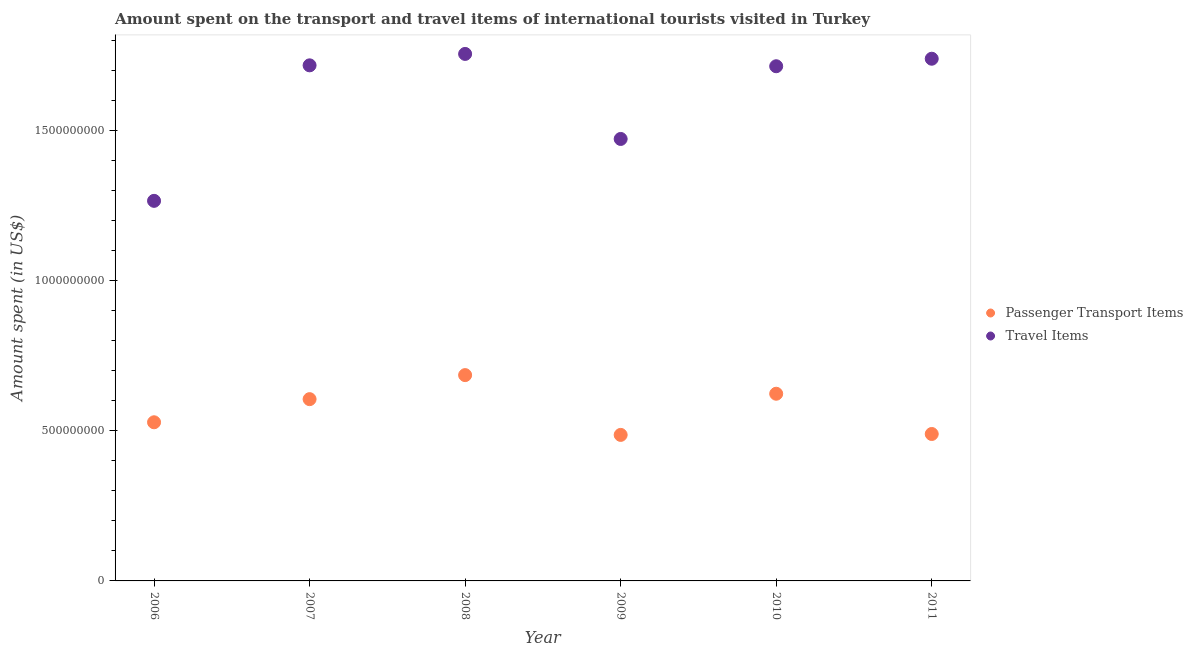How many different coloured dotlines are there?
Keep it short and to the point. 2. Is the number of dotlines equal to the number of legend labels?
Ensure brevity in your answer.  Yes. What is the amount spent on passenger transport items in 2007?
Your answer should be compact. 6.05e+08. Across all years, what is the maximum amount spent on passenger transport items?
Your answer should be very brief. 6.85e+08. Across all years, what is the minimum amount spent in travel items?
Your answer should be compact. 1.26e+09. In which year was the amount spent in travel items maximum?
Ensure brevity in your answer.  2008. What is the total amount spent on passenger transport items in the graph?
Make the answer very short. 3.42e+09. What is the difference between the amount spent on passenger transport items in 2008 and that in 2010?
Provide a short and direct response. 6.20e+07. What is the difference between the amount spent in travel items in 2006 and the amount spent on passenger transport items in 2009?
Offer a very short reply. 7.79e+08. What is the average amount spent on passenger transport items per year?
Give a very brief answer. 5.69e+08. In the year 2011, what is the difference between the amount spent in travel items and amount spent on passenger transport items?
Your response must be concise. 1.25e+09. What is the ratio of the amount spent on passenger transport items in 2008 to that in 2010?
Make the answer very short. 1.1. Is the amount spent in travel items in 2006 less than that in 2011?
Offer a very short reply. Yes. Is the difference between the amount spent on passenger transport items in 2008 and 2010 greater than the difference between the amount spent in travel items in 2008 and 2010?
Your answer should be very brief. Yes. What is the difference between the highest and the second highest amount spent on passenger transport items?
Your answer should be very brief. 6.20e+07. What is the difference between the highest and the lowest amount spent in travel items?
Make the answer very short. 4.89e+08. Is the amount spent on passenger transport items strictly less than the amount spent in travel items over the years?
Your answer should be very brief. Yes. What is the difference between two consecutive major ticks on the Y-axis?
Provide a succinct answer. 5.00e+08. Are the values on the major ticks of Y-axis written in scientific E-notation?
Provide a short and direct response. No. Does the graph contain any zero values?
Make the answer very short. No. How many legend labels are there?
Your response must be concise. 2. What is the title of the graph?
Keep it short and to the point. Amount spent on the transport and travel items of international tourists visited in Turkey. What is the label or title of the Y-axis?
Provide a succinct answer. Amount spent (in US$). What is the Amount spent (in US$) in Passenger Transport Items in 2006?
Offer a very short reply. 5.28e+08. What is the Amount spent (in US$) of Travel Items in 2006?
Provide a succinct answer. 1.26e+09. What is the Amount spent (in US$) of Passenger Transport Items in 2007?
Give a very brief answer. 6.05e+08. What is the Amount spent (in US$) of Travel Items in 2007?
Provide a short and direct response. 1.72e+09. What is the Amount spent (in US$) in Passenger Transport Items in 2008?
Your answer should be very brief. 6.85e+08. What is the Amount spent (in US$) in Travel Items in 2008?
Ensure brevity in your answer.  1.75e+09. What is the Amount spent (in US$) of Passenger Transport Items in 2009?
Make the answer very short. 4.86e+08. What is the Amount spent (in US$) of Travel Items in 2009?
Offer a terse response. 1.47e+09. What is the Amount spent (in US$) in Passenger Transport Items in 2010?
Your answer should be compact. 6.23e+08. What is the Amount spent (in US$) in Travel Items in 2010?
Give a very brief answer. 1.71e+09. What is the Amount spent (in US$) of Passenger Transport Items in 2011?
Ensure brevity in your answer.  4.89e+08. What is the Amount spent (in US$) in Travel Items in 2011?
Give a very brief answer. 1.74e+09. Across all years, what is the maximum Amount spent (in US$) in Passenger Transport Items?
Provide a short and direct response. 6.85e+08. Across all years, what is the maximum Amount spent (in US$) of Travel Items?
Offer a very short reply. 1.75e+09. Across all years, what is the minimum Amount spent (in US$) of Passenger Transport Items?
Offer a terse response. 4.86e+08. Across all years, what is the minimum Amount spent (in US$) of Travel Items?
Provide a succinct answer. 1.26e+09. What is the total Amount spent (in US$) in Passenger Transport Items in the graph?
Ensure brevity in your answer.  3.42e+09. What is the total Amount spent (in US$) of Travel Items in the graph?
Your answer should be very brief. 9.66e+09. What is the difference between the Amount spent (in US$) in Passenger Transport Items in 2006 and that in 2007?
Ensure brevity in your answer.  -7.70e+07. What is the difference between the Amount spent (in US$) of Travel Items in 2006 and that in 2007?
Make the answer very short. -4.51e+08. What is the difference between the Amount spent (in US$) of Passenger Transport Items in 2006 and that in 2008?
Your answer should be very brief. -1.57e+08. What is the difference between the Amount spent (in US$) in Travel Items in 2006 and that in 2008?
Offer a very short reply. -4.89e+08. What is the difference between the Amount spent (in US$) of Passenger Transport Items in 2006 and that in 2009?
Offer a very short reply. 4.20e+07. What is the difference between the Amount spent (in US$) in Travel Items in 2006 and that in 2009?
Provide a succinct answer. -2.06e+08. What is the difference between the Amount spent (in US$) in Passenger Transport Items in 2006 and that in 2010?
Provide a short and direct response. -9.50e+07. What is the difference between the Amount spent (in US$) in Travel Items in 2006 and that in 2010?
Give a very brief answer. -4.48e+08. What is the difference between the Amount spent (in US$) in Passenger Transport Items in 2006 and that in 2011?
Make the answer very short. 3.90e+07. What is the difference between the Amount spent (in US$) of Travel Items in 2006 and that in 2011?
Offer a terse response. -4.73e+08. What is the difference between the Amount spent (in US$) in Passenger Transport Items in 2007 and that in 2008?
Provide a succinct answer. -8.00e+07. What is the difference between the Amount spent (in US$) of Travel Items in 2007 and that in 2008?
Provide a short and direct response. -3.80e+07. What is the difference between the Amount spent (in US$) of Passenger Transport Items in 2007 and that in 2009?
Make the answer very short. 1.19e+08. What is the difference between the Amount spent (in US$) of Travel Items in 2007 and that in 2009?
Provide a short and direct response. 2.45e+08. What is the difference between the Amount spent (in US$) in Passenger Transport Items in 2007 and that in 2010?
Offer a terse response. -1.80e+07. What is the difference between the Amount spent (in US$) in Passenger Transport Items in 2007 and that in 2011?
Give a very brief answer. 1.16e+08. What is the difference between the Amount spent (in US$) in Travel Items in 2007 and that in 2011?
Your answer should be compact. -2.20e+07. What is the difference between the Amount spent (in US$) of Passenger Transport Items in 2008 and that in 2009?
Your answer should be very brief. 1.99e+08. What is the difference between the Amount spent (in US$) in Travel Items in 2008 and that in 2009?
Your answer should be very brief. 2.83e+08. What is the difference between the Amount spent (in US$) in Passenger Transport Items in 2008 and that in 2010?
Your answer should be compact. 6.20e+07. What is the difference between the Amount spent (in US$) in Travel Items in 2008 and that in 2010?
Make the answer very short. 4.10e+07. What is the difference between the Amount spent (in US$) of Passenger Transport Items in 2008 and that in 2011?
Your response must be concise. 1.96e+08. What is the difference between the Amount spent (in US$) of Travel Items in 2008 and that in 2011?
Your answer should be compact. 1.60e+07. What is the difference between the Amount spent (in US$) in Passenger Transport Items in 2009 and that in 2010?
Keep it short and to the point. -1.37e+08. What is the difference between the Amount spent (in US$) in Travel Items in 2009 and that in 2010?
Offer a terse response. -2.42e+08. What is the difference between the Amount spent (in US$) of Passenger Transport Items in 2009 and that in 2011?
Give a very brief answer. -3.00e+06. What is the difference between the Amount spent (in US$) of Travel Items in 2009 and that in 2011?
Give a very brief answer. -2.67e+08. What is the difference between the Amount spent (in US$) in Passenger Transport Items in 2010 and that in 2011?
Give a very brief answer. 1.34e+08. What is the difference between the Amount spent (in US$) of Travel Items in 2010 and that in 2011?
Your answer should be very brief. -2.50e+07. What is the difference between the Amount spent (in US$) in Passenger Transport Items in 2006 and the Amount spent (in US$) in Travel Items in 2007?
Your response must be concise. -1.19e+09. What is the difference between the Amount spent (in US$) of Passenger Transport Items in 2006 and the Amount spent (in US$) of Travel Items in 2008?
Your answer should be compact. -1.23e+09. What is the difference between the Amount spent (in US$) of Passenger Transport Items in 2006 and the Amount spent (in US$) of Travel Items in 2009?
Provide a succinct answer. -9.43e+08. What is the difference between the Amount spent (in US$) of Passenger Transport Items in 2006 and the Amount spent (in US$) of Travel Items in 2010?
Offer a terse response. -1.18e+09. What is the difference between the Amount spent (in US$) of Passenger Transport Items in 2006 and the Amount spent (in US$) of Travel Items in 2011?
Provide a succinct answer. -1.21e+09. What is the difference between the Amount spent (in US$) in Passenger Transport Items in 2007 and the Amount spent (in US$) in Travel Items in 2008?
Give a very brief answer. -1.15e+09. What is the difference between the Amount spent (in US$) in Passenger Transport Items in 2007 and the Amount spent (in US$) in Travel Items in 2009?
Your response must be concise. -8.66e+08. What is the difference between the Amount spent (in US$) of Passenger Transport Items in 2007 and the Amount spent (in US$) of Travel Items in 2010?
Offer a terse response. -1.11e+09. What is the difference between the Amount spent (in US$) in Passenger Transport Items in 2007 and the Amount spent (in US$) in Travel Items in 2011?
Provide a succinct answer. -1.13e+09. What is the difference between the Amount spent (in US$) of Passenger Transport Items in 2008 and the Amount spent (in US$) of Travel Items in 2009?
Offer a terse response. -7.86e+08. What is the difference between the Amount spent (in US$) of Passenger Transport Items in 2008 and the Amount spent (in US$) of Travel Items in 2010?
Your answer should be compact. -1.03e+09. What is the difference between the Amount spent (in US$) of Passenger Transport Items in 2008 and the Amount spent (in US$) of Travel Items in 2011?
Keep it short and to the point. -1.05e+09. What is the difference between the Amount spent (in US$) of Passenger Transport Items in 2009 and the Amount spent (in US$) of Travel Items in 2010?
Your answer should be very brief. -1.23e+09. What is the difference between the Amount spent (in US$) of Passenger Transport Items in 2009 and the Amount spent (in US$) of Travel Items in 2011?
Provide a succinct answer. -1.25e+09. What is the difference between the Amount spent (in US$) of Passenger Transport Items in 2010 and the Amount spent (in US$) of Travel Items in 2011?
Offer a very short reply. -1.12e+09. What is the average Amount spent (in US$) of Passenger Transport Items per year?
Offer a terse response. 5.69e+08. What is the average Amount spent (in US$) of Travel Items per year?
Your answer should be compact. 1.61e+09. In the year 2006, what is the difference between the Amount spent (in US$) of Passenger Transport Items and Amount spent (in US$) of Travel Items?
Your answer should be compact. -7.37e+08. In the year 2007, what is the difference between the Amount spent (in US$) in Passenger Transport Items and Amount spent (in US$) in Travel Items?
Your response must be concise. -1.11e+09. In the year 2008, what is the difference between the Amount spent (in US$) of Passenger Transport Items and Amount spent (in US$) of Travel Items?
Offer a very short reply. -1.07e+09. In the year 2009, what is the difference between the Amount spent (in US$) in Passenger Transport Items and Amount spent (in US$) in Travel Items?
Offer a terse response. -9.85e+08. In the year 2010, what is the difference between the Amount spent (in US$) in Passenger Transport Items and Amount spent (in US$) in Travel Items?
Your response must be concise. -1.09e+09. In the year 2011, what is the difference between the Amount spent (in US$) in Passenger Transport Items and Amount spent (in US$) in Travel Items?
Offer a very short reply. -1.25e+09. What is the ratio of the Amount spent (in US$) in Passenger Transport Items in 2006 to that in 2007?
Give a very brief answer. 0.87. What is the ratio of the Amount spent (in US$) of Travel Items in 2006 to that in 2007?
Your response must be concise. 0.74. What is the ratio of the Amount spent (in US$) of Passenger Transport Items in 2006 to that in 2008?
Give a very brief answer. 0.77. What is the ratio of the Amount spent (in US$) of Travel Items in 2006 to that in 2008?
Keep it short and to the point. 0.72. What is the ratio of the Amount spent (in US$) of Passenger Transport Items in 2006 to that in 2009?
Make the answer very short. 1.09. What is the ratio of the Amount spent (in US$) of Travel Items in 2006 to that in 2009?
Keep it short and to the point. 0.86. What is the ratio of the Amount spent (in US$) in Passenger Transport Items in 2006 to that in 2010?
Give a very brief answer. 0.85. What is the ratio of the Amount spent (in US$) in Travel Items in 2006 to that in 2010?
Offer a terse response. 0.74. What is the ratio of the Amount spent (in US$) of Passenger Transport Items in 2006 to that in 2011?
Keep it short and to the point. 1.08. What is the ratio of the Amount spent (in US$) in Travel Items in 2006 to that in 2011?
Offer a very short reply. 0.73. What is the ratio of the Amount spent (in US$) of Passenger Transport Items in 2007 to that in 2008?
Your answer should be compact. 0.88. What is the ratio of the Amount spent (in US$) of Travel Items in 2007 to that in 2008?
Give a very brief answer. 0.98. What is the ratio of the Amount spent (in US$) in Passenger Transport Items in 2007 to that in 2009?
Make the answer very short. 1.24. What is the ratio of the Amount spent (in US$) in Travel Items in 2007 to that in 2009?
Give a very brief answer. 1.17. What is the ratio of the Amount spent (in US$) of Passenger Transport Items in 2007 to that in 2010?
Your response must be concise. 0.97. What is the ratio of the Amount spent (in US$) of Travel Items in 2007 to that in 2010?
Your answer should be compact. 1. What is the ratio of the Amount spent (in US$) of Passenger Transport Items in 2007 to that in 2011?
Provide a succinct answer. 1.24. What is the ratio of the Amount spent (in US$) of Travel Items in 2007 to that in 2011?
Your response must be concise. 0.99. What is the ratio of the Amount spent (in US$) in Passenger Transport Items in 2008 to that in 2009?
Provide a short and direct response. 1.41. What is the ratio of the Amount spent (in US$) of Travel Items in 2008 to that in 2009?
Offer a terse response. 1.19. What is the ratio of the Amount spent (in US$) of Passenger Transport Items in 2008 to that in 2010?
Offer a terse response. 1.1. What is the ratio of the Amount spent (in US$) in Travel Items in 2008 to that in 2010?
Keep it short and to the point. 1.02. What is the ratio of the Amount spent (in US$) in Passenger Transport Items in 2008 to that in 2011?
Give a very brief answer. 1.4. What is the ratio of the Amount spent (in US$) of Travel Items in 2008 to that in 2011?
Keep it short and to the point. 1.01. What is the ratio of the Amount spent (in US$) in Passenger Transport Items in 2009 to that in 2010?
Provide a short and direct response. 0.78. What is the ratio of the Amount spent (in US$) in Travel Items in 2009 to that in 2010?
Keep it short and to the point. 0.86. What is the ratio of the Amount spent (in US$) in Travel Items in 2009 to that in 2011?
Your answer should be compact. 0.85. What is the ratio of the Amount spent (in US$) of Passenger Transport Items in 2010 to that in 2011?
Your answer should be very brief. 1.27. What is the ratio of the Amount spent (in US$) in Travel Items in 2010 to that in 2011?
Ensure brevity in your answer.  0.99. What is the difference between the highest and the second highest Amount spent (in US$) of Passenger Transport Items?
Offer a terse response. 6.20e+07. What is the difference between the highest and the second highest Amount spent (in US$) of Travel Items?
Your response must be concise. 1.60e+07. What is the difference between the highest and the lowest Amount spent (in US$) of Passenger Transport Items?
Provide a short and direct response. 1.99e+08. What is the difference between the highest and the lowest Amount spent (in US$) in Travel Items?
Offer a terse response. 4.89e+08. 